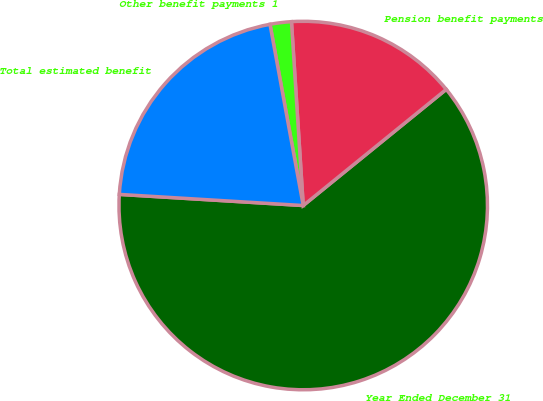<chart> <loc_0><loc_0><loc_500><loc_500><pie_chart><fcel>Year Ended December 31<fcel>Pension benefit payments<fcel>Other benefit payments 1<fcel>Total estimated benefit<nl><fcel>61.82%<fcel>15.16%<fcel>1.87%<fcel>21.15%<nl></chart> 